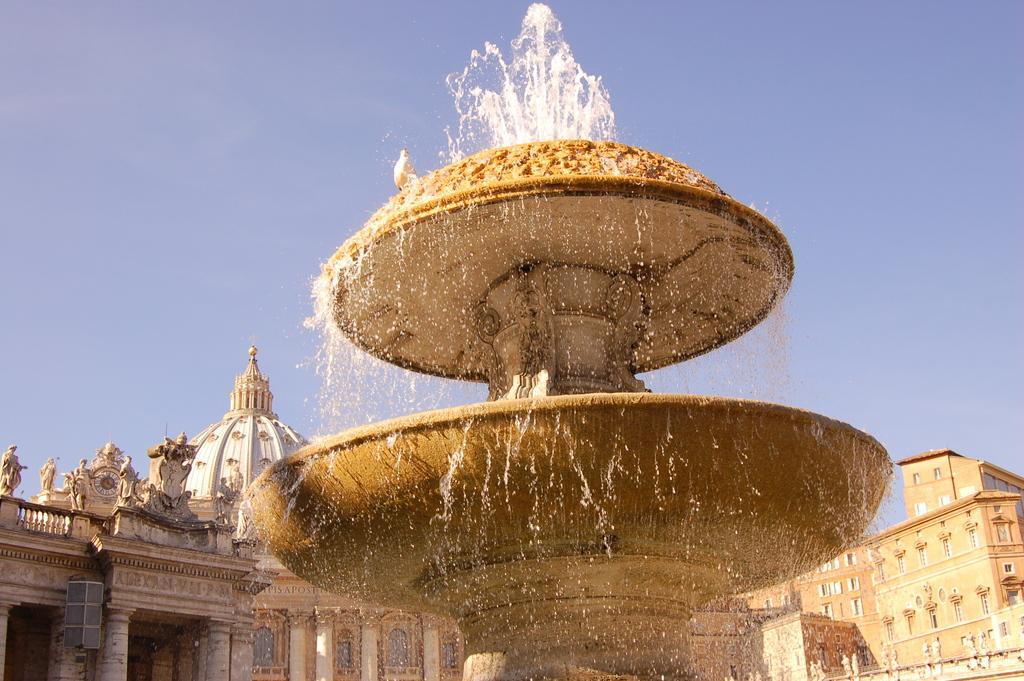In one or two sentences, can you explain what this image depicts? In this image there is a fountain, in the background there is a monument and a sky. 